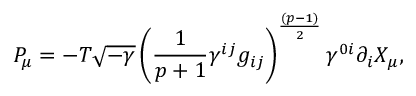Convert formula to latex. <formula><loc_0><loc_0><loc_500><loc_500>P _ { \mu } = - T \sqrt { - \gamma } \left ( { \frac { 1 } { p + 1 } } \gamma ^ { i j } g _ { i j } \right ) ^ { \frac { ( p - 1 ) } { 2 } } \gamma ^ { 0 i } \partial _ { i } X _ { \mu } ,</formula> 